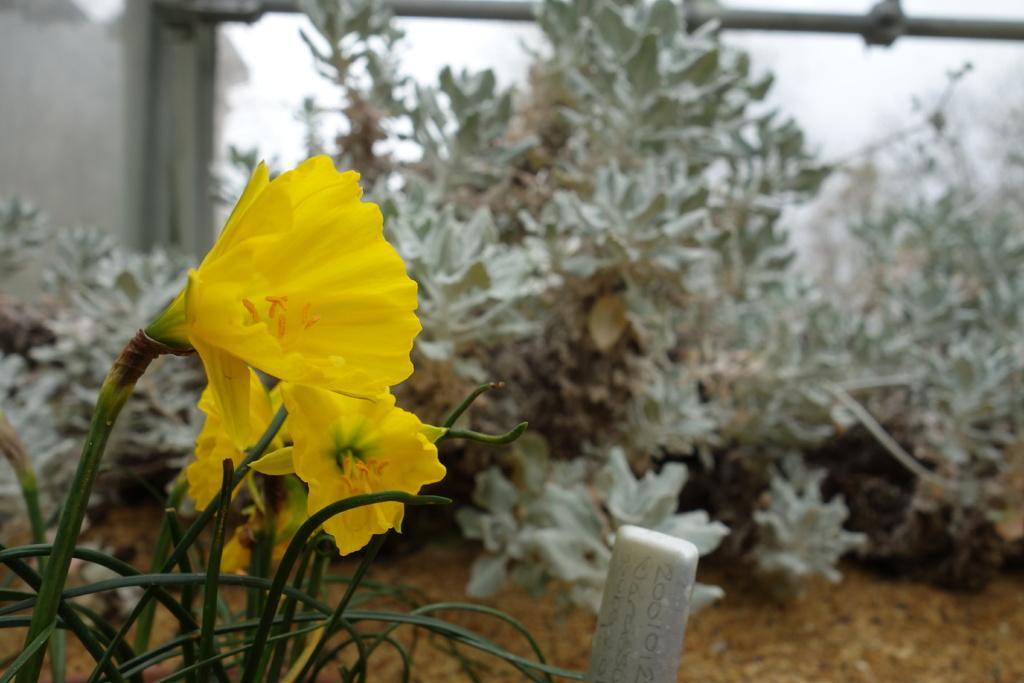What type of plants can be seen in the image? There are flower plants in the image. What is written on the marble in the image? There is marble with text in the image. What can be seen in the background of the image? There are plants and the ground visible in the background of the image. What architectural feature is present in the background of the image? There is a rod in the background of the image. Can you hear the plants laughing in the image? Plants do not have the ability to laugh, so there is no laughter present in the image. 